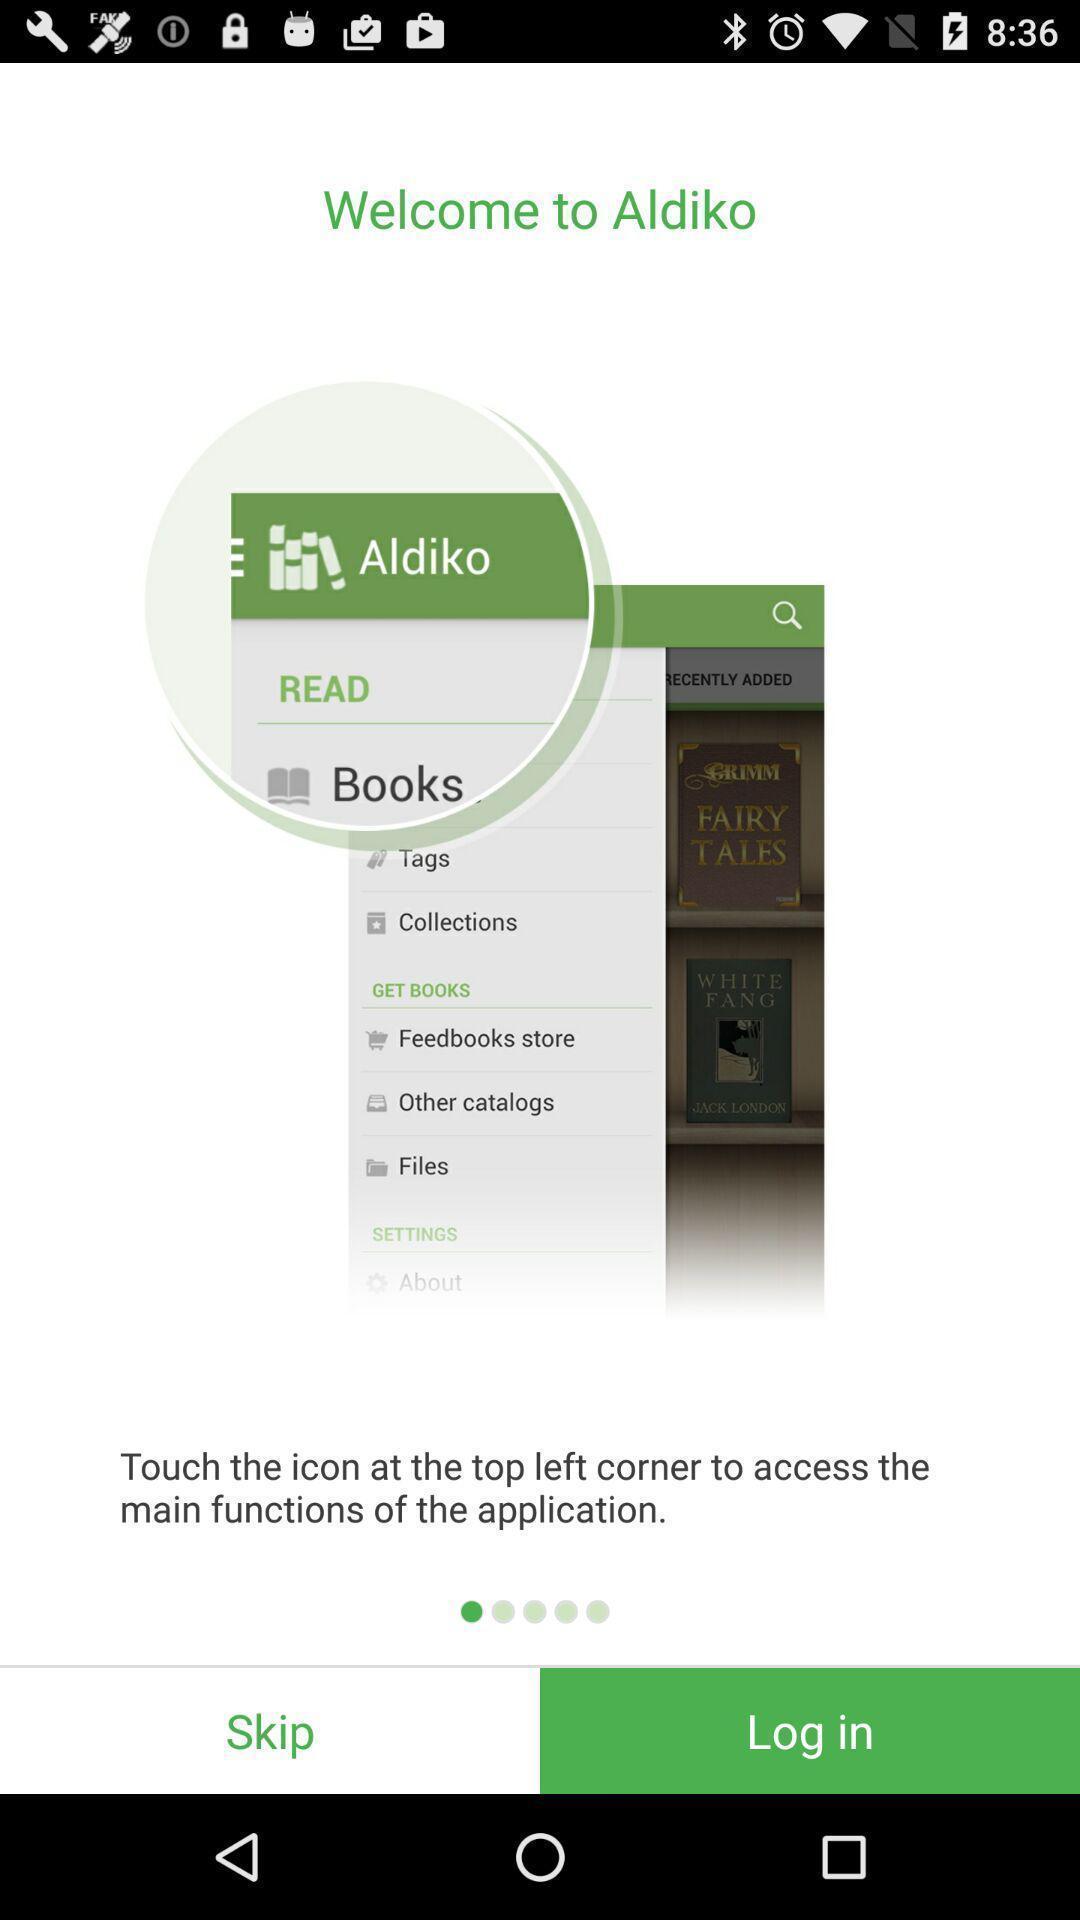Explain the elements present in this screenshot. Welcome page of an ebook application. 